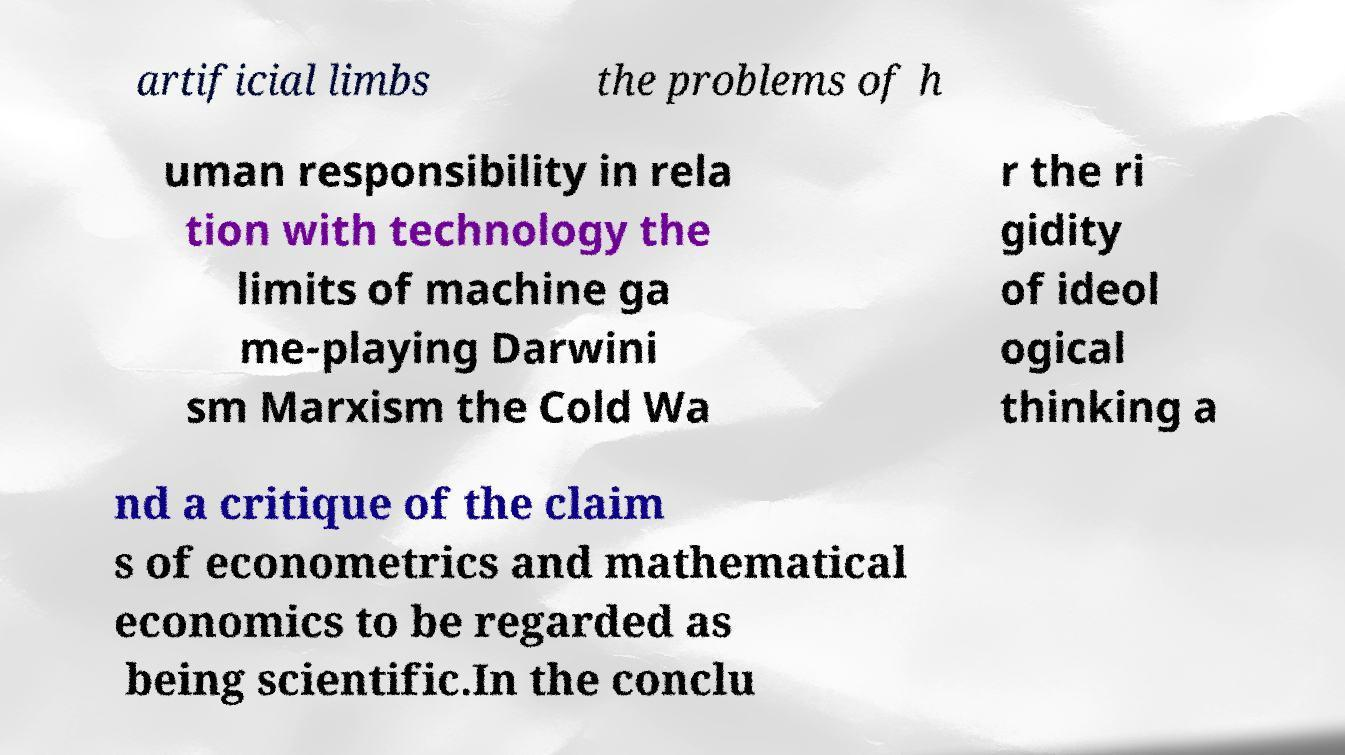Could you extract and type out the text from this image? artificial limbs the problems of h uman responsibility in rela tion with technology the limits of machine ga me-playing Darwini sm Marxism the Cold Wa r the ri gidity of ideol ogical thinking a nd a critique of the claim s of econometrics and mathematical economics to be regarded as being scientific.In the conclu 